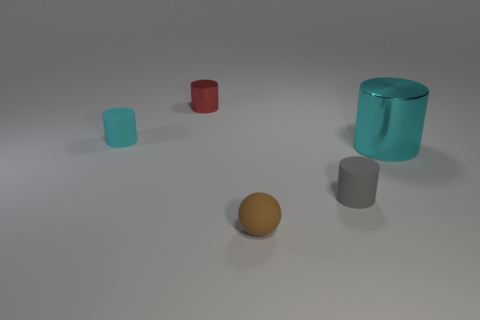Do these objects look like they are part of a collection or do they serve individual purposes? The objects vary in shape, size, and color which could imply that they serve different purposes or belong to different sets. The cyan cylinder appears to be a container and might be related to storage or display due to its transparency and stature, while the solid-colored brown sphere and smaller cyan cube suggest more utilitarian or decorative functions. Their diverse appearances do not suggest they form a cohesive collection designed to be used together. 